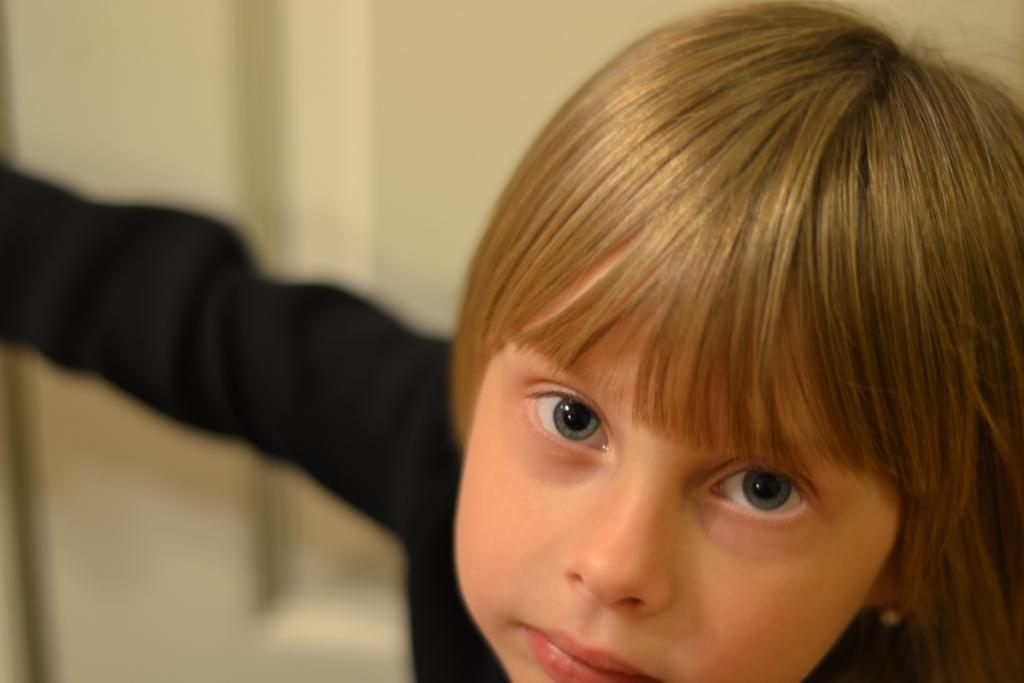Could you give a brief overview of what you see in this image? In this picture I can see a boy in front, who is wearing black color dress and I see that it is blurred in the background. 